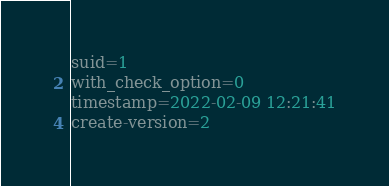Convert code to text. <code><loc_0><loc_0><loc_500><loc_500><_VisualBasic_>suid=1
with_check_option=0
timestamp=2022-02-09 12:21:41
create-version=2</code> 